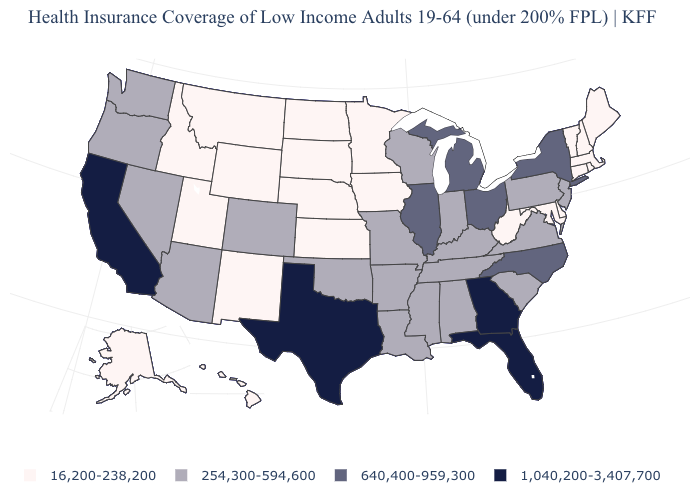Does Massachusetts have a lower value than Pennsylvania?
Answer briefly. Yes. Does the first symbol in the legend represent the smallest category?
Short answer required. Yes. Among the states that border Rhode Island , which have the highest value?
Quick response, please. Connecticut, Massachusetts. Among the states that border Maine , which have the highest value?
Quick response, please. New Hampshire. What is the value of New Jersey?
Give a very brief answer. 254,300-594,600. Does New Mexico have the lowest value in the USA?
Answer briefly. Yes. Which states have the lowest value in the South?
Be succinct. Delaware, Maryland, West Virginia. How many symbols are there in the legend?
Quick response, please. 4. Is the legend a continuous bar?
Concise answer only. No. Among the states that border Maryland , does Delaware have the lowest value?
Write a very short answer. Yes. Does Vermont have a higher value than Mississippi?
Answer briefly. No. What is the highest value in the South ?
Short answer required. 1,040,200-3,407,700. Among the states that border Missouri , which have the lowest value?
Be succinct. Iowa, Kansas, Nebraska. Does Tennessee have the lowest value in the South?
Be succinct. No. Name the states that have a value in the range 16,200-238,200?
Be succinct. Alaska, Connecticut, Delaware, Hawaii, Idaho, Iowa, Kansas, Maine, Maryland, Massachusetts, Minnesota, Montana, Nebraska, New Hampshire, New Mexico, North Dakota, Rhode Island, South Dakota, Utah, Vermont, West Virginia, Wyoming. 